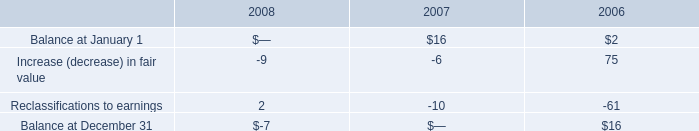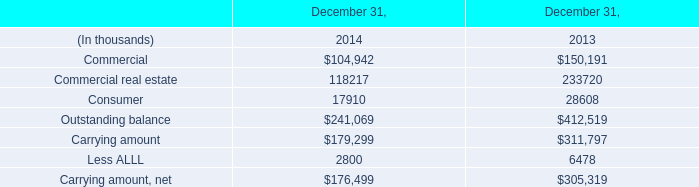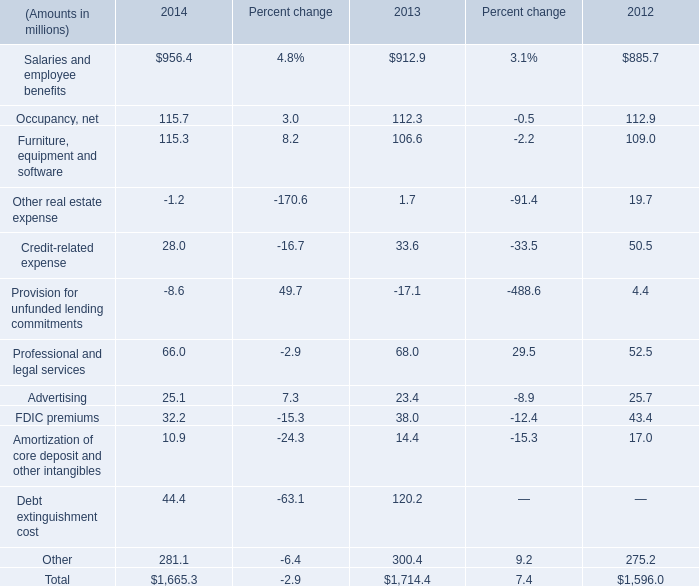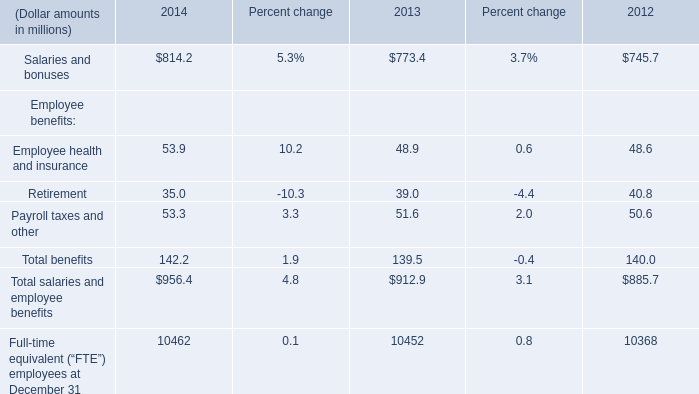Does the average value of Salaries and employee benefits in 2014 greater than that in 2013? 
Answer: yes. 